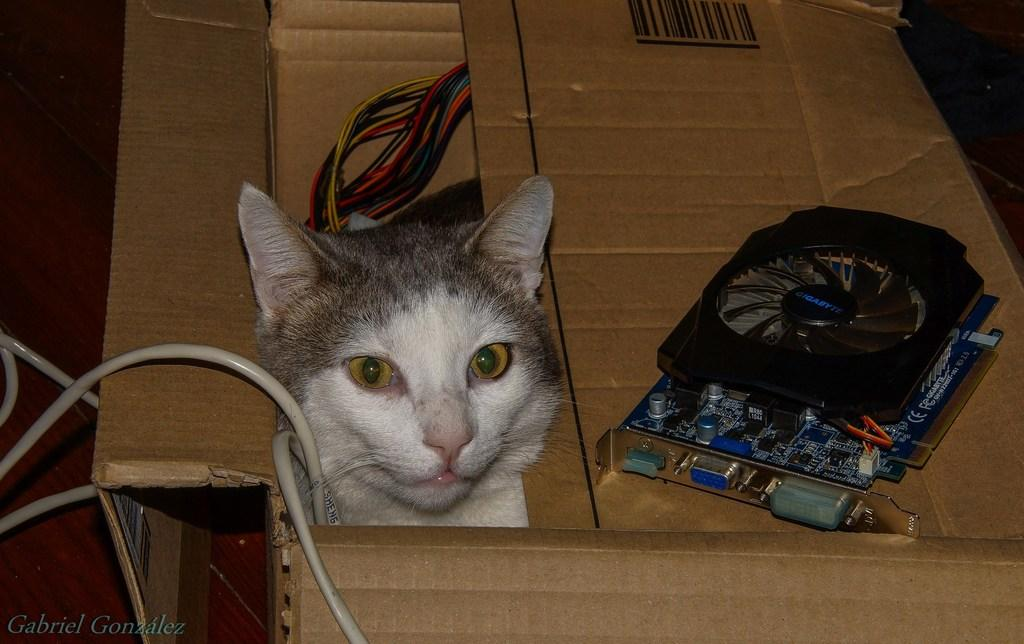What is the surface on which the cardboard box is placed? The cardboard box is on a brown surface. What can be found inside the cardboard box? There is a cat, cables, and a motherboard in the cardboard box. What is the color of the watermark in the image? The watermark is on the left side of the image, but there is no information about its color. What note is the cat playing on the brown surface? There is no indication in the image that the cat is playing a musical instrument or note. 